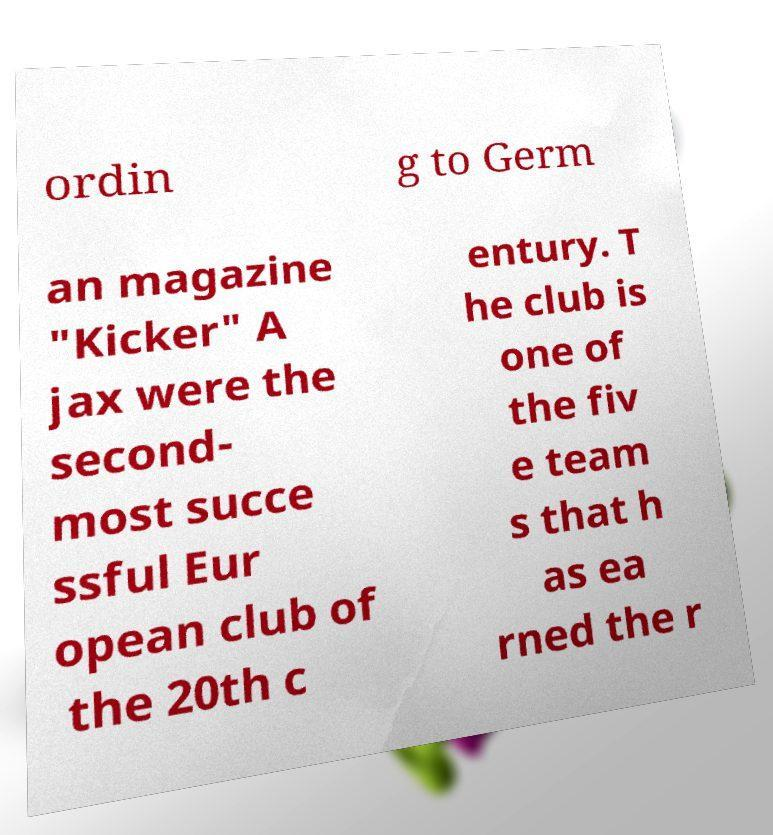Could you assist in decoding the text presented in this image and type it out clearly? ordin g to Germ an magazine "Kicker" A jax were the second- most succe ssful Eur opean club of the 20th c entury. T he club is one of the fiv e team s that h as ea rned the r 